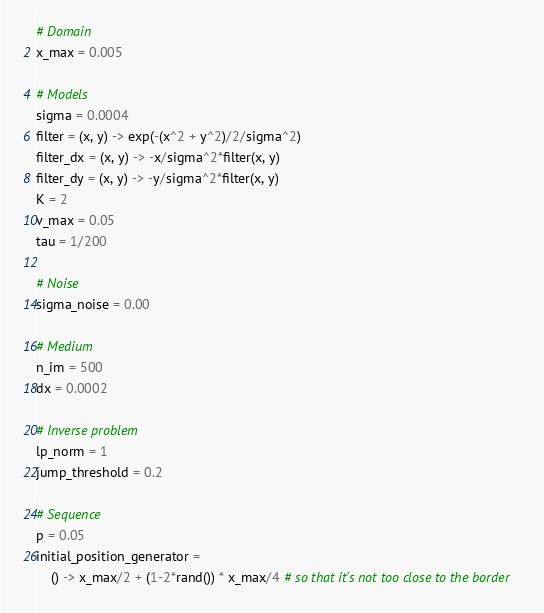Convert code to text. <code><loc_0><loc_0><loc_500><loc_500><_Julia_># Domain
x_max = 0.005

# Models
sigma = 0.0004
filter = (x, y) -> exp(-(x^2 + y^2)/2/sigma^2)
filter_dx = (x, y) -> -x/sigma^2*filter(x, y)
filter_dy = (x, y) -> -y/sigma^2*filter(x, y)
K = 2
v_max = 0.05
tau = 1/200

# Noise
sigma_noise = 0.00

# Medium
n_im = 500
dx = 0.0002

# Inverse problem
lp_norm = 1
jump_threshold = 0.2

# Sequence
p = 0.05
initial_position_generator = 
    () -> x_max/2 + (1-2*rand()) * x_max/4 # so that it's not too close to the border
</code> 